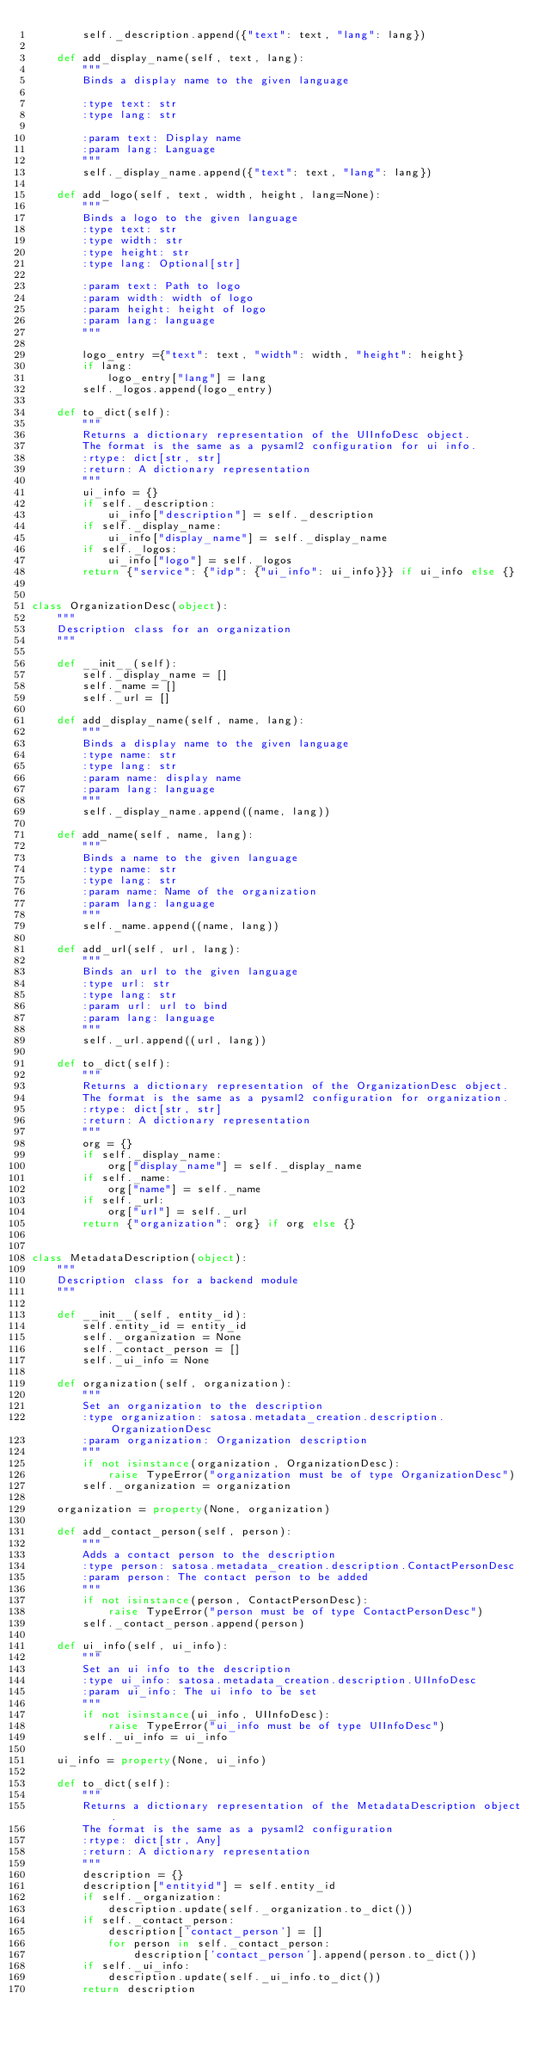Convert code to text. <code><loc_0><loc_0><loc_500><loc_500><_Python_>        self._description.append({"text": text, "lang": lang})

    def add_display_name(self, text, lang):
        """
        Binds a display name to the given language

        :type text: str
        :type lang: str

        :param text: Display name
        :param lang: Language
        """
        self._display_name.append({"text": text, "lang": lang})

    def add_logo(self, text, width, height, lang=None):
        """
        Binds a logo to the given language
        :type text: str
        :type width: str
        :type height: str
        :type lang: Optional[str]

        :param text: Path to logo
        :param width: width of logo
        :param height: height of logo
        :param lang: language
        """

        logo_entry ={"text": text, "width": width, "height": height}
        if lang:
            logo_entry["lang"] = lang
        self._logos.append(logo_entry)

    def to_dict(self):
        """
        Returns a dictionary representation of the UIInfoDesc object.
        The format is the same as a pysaml2 configuration for ui info.
        :rtype: dict[str, str]
        :return: A dictionary representation
        """
        ui_info = {}
        if self._description:
            ui_info["description"] = self._description
        if self._display_name:
            ui_info["display_name"] = self._display_name
        if self._logos:
            ui_info["logo"] = self._logos
        return {"service": {"idp": {"ui_info": ui_info}}} if ui_info else {}


class OrganizationDesc(object):
    """
    Description class for an organization
    """

    def __init__(self):
        self._display_name = []
        self._name = []
        self._url = []

    def add_display_name(self, name, lang):
        """
        Binds a display name to the given language
        :type name: str
        :type lang: str
        :param name: display name
        :param lang: language
        """
        self._display_name.append((name, lang))

    def add_name(self, name, lang):
        """
        Binds a name to the given language
        :type name: str
        :type lang: str
        :param name: Name of the organization
        :param lang: language
        """
        self._name.append((name, lang))

    def add_url(self, url, lang):
        """
        Binds an url to the given language
        :type url: str
        :type lang: str
        :param url: url to bind
        :param lang: language
        """
        self._url.append((url, lang))

    def to_dict(self):
        """
        Returns a dictionary representation of the OrganizationDesc object.
        The format is the same as a pysaml2 configuration for organization.
        :rtype: dict[str, str]
        :return: A dictionary representation
        """
        org = {}
        if self._display_name:
            org["display_name"] = self._display_name
        if self._name:
            org["name"] = self._name
        if self._url:
            org["url"] = self._url
        return {"organization": org} if org else {}


class MetadataDescription(object):
    """
    Description class for a backend module
    """

    def __init__(self, entity_id):
        self.entity_id = entity_id
        self._organization = None
        self._contact_person = []
        self._ui_info = None

    def organization(self, organization):
        """
        Set an organization to the description
        :type organization: satosa.metadata_creation.description.OrganizationDesc
        :param organization: Organization description
        """
        if not isinstance(organization, OrganizationDesc):
            raise TypeError("organization must be of type OrganizationDesc")
        self._organization = organization

    organization = property(None, organization)

    def add_contact_person(self, person):
        """
        Adds a contact person to the description
        :type person: satosa.metadata_creation.description.ContactPersonDesc
        :param person: The contact person to be added
        """
        if not isinstance(person, ContactPersonDesc):
            raise TypeError("person must be of type ContactPersonDesc")
        self._contact_person.append(person)

    def ui_info(self, ui_info):
        """
        Set an ui info to the description
        :type ui_info: satosa.metadata_creation.description.UIInfoDesc
        :param ui_info: The ui info to be set
        """
        if not isinstance(ui_info, UIInfoDesc):
            raise TypeError("ui_info must be of type UIInfoDesc")
        self._ui_info = ui_info

    ui_info = property(None, ui_info)

    def to_dict(self):
        """
        Returns a dictionary representation of the MetadataDescription object.
        The format is the same as a pysaml2 configuration
        :rtype: dict[str, Any]
        :return: A dictionary representation
        """
        description = {}
        description["entityid"] = self.entity_id
        if self._organization:
            description.update(self._organization.to_dict())
        if self._contact_person:
            description['contact_person'] = []
            for person in self._contact_person:
                description['contact_person'].append(person.to_dict())
        if self._ui_info:
            description.update(self._ui_info.to_dict())
        return description
</code> 